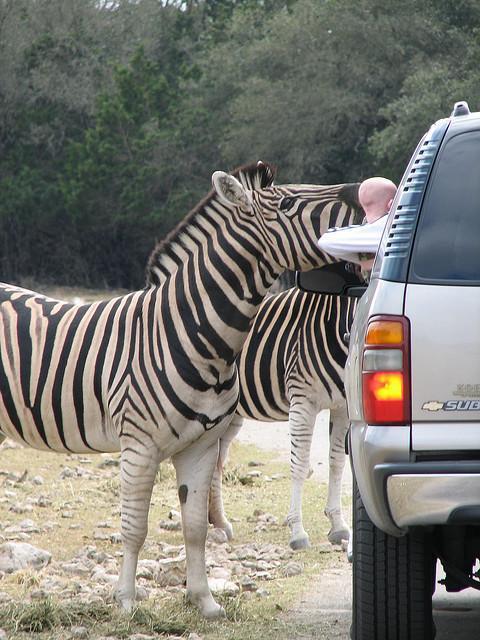How many zebras are in the picture?
Give a very brief answer. 2. How many zebras can you see?
Give a very brief answer. 2. How many kites do you see?
Give a very brief answer. 0. 